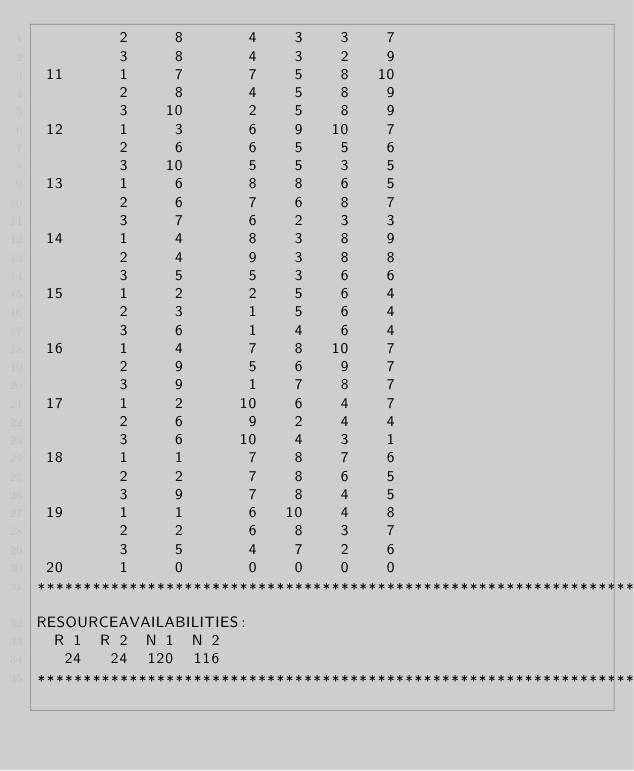<code> <loc_0><loc_0><loc_500><loc_500><_ObjectiveC_>         2     8       4    3    3    7
         3     8       4    3    2    9
 11      1     7       7    5    8   10
         2     8       4    5    8    9
         3    10       2    5    8    9
 12      1     3       6    9   10    7
         2     6       6    5    5    6
         3    10       5    5    3    5
 13      1     6       8    8    6    5
         2     6       7    6    8    7
         3     7       6    2    3    3
 14      1     4       8    3    8    9
         2     4       9    3    8    8
         3     5       5    3    6    6
 15      1     2       2    5    6    4
         2     3       1    5    6    4
         3     6       1    4    6    4
 16      1     4       7    8   10    7
         2     9       5    6    9    7
         3     9       1    7    8    7
 17      1     2      10    6    4    7
         2     6       9    2    4    4
         3     6      10    4    3    1
 18      1     1       7    8    7    6
         2     2       7    8    6    5
         3     9       7    8    4    5
 19      1     1       6   10    4    8
         2     2       6    8    3    7
         3     5       4    7    2    6
 20      1     0       0    0    0    0
************************************************************************
RESOURCEAVAILABILITIES:
  R 1  R 2  N 1  N 2
   24   24  120  116
************************************************************************
</code> 